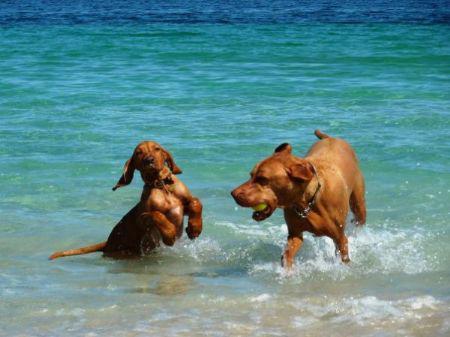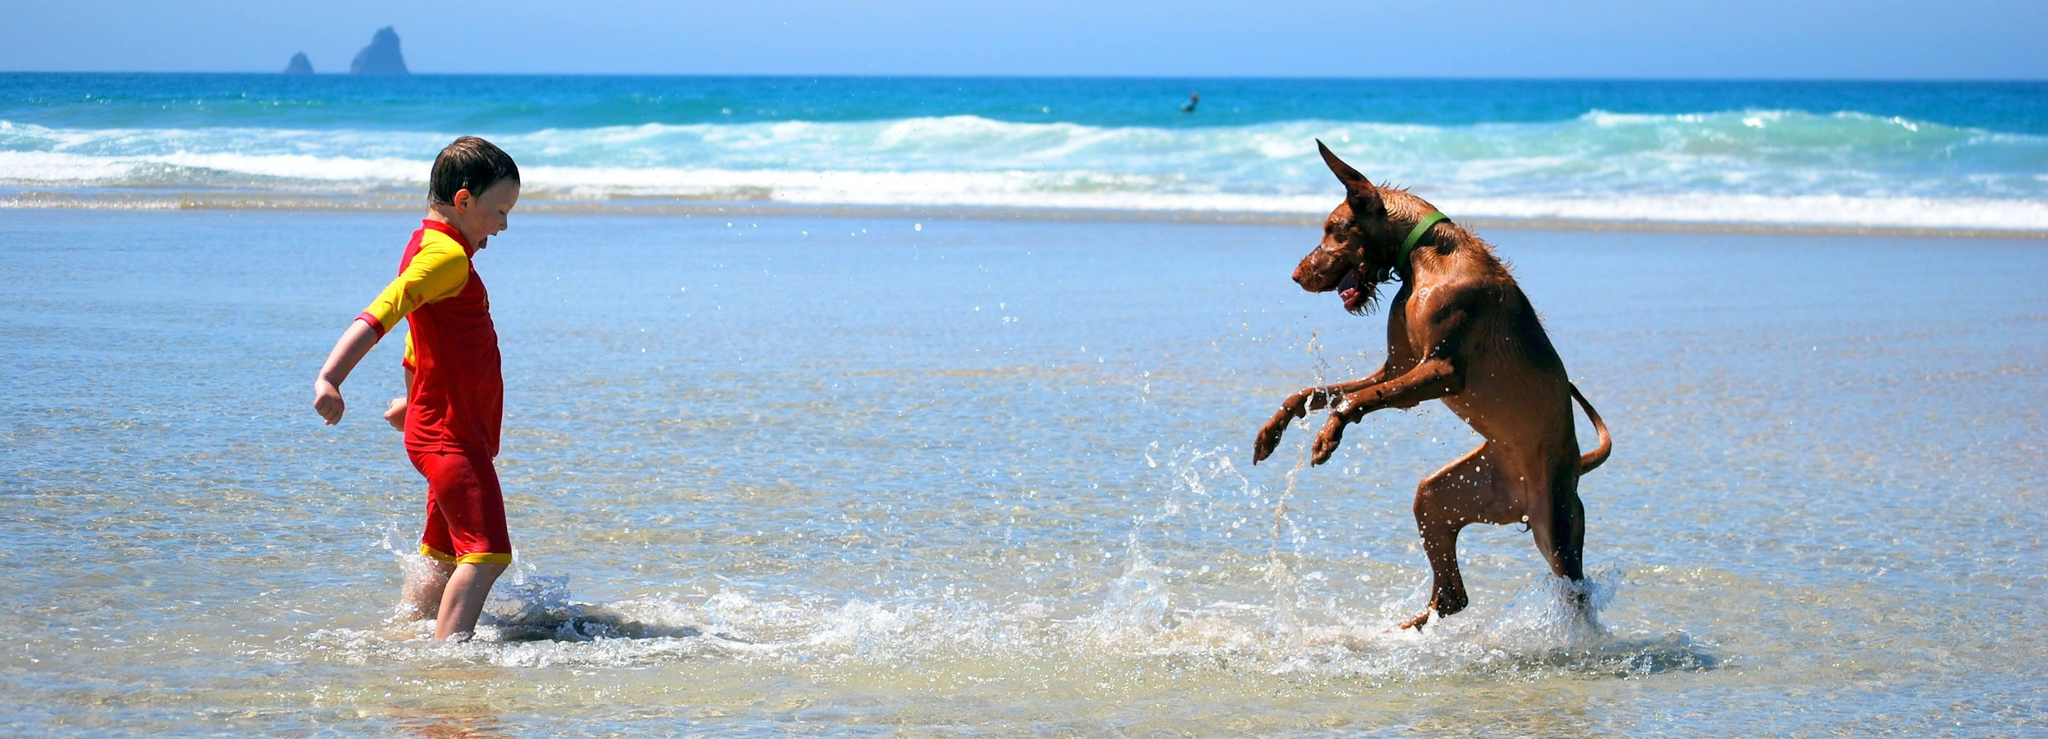The first image is the image on the left, the second image is the image on the right. For the images shown, is this caption "A boy and a dog face toward each other in one image, and two dogs are in a natural body of water in the other image." true? Answer yes or no. Yes. The first image is the image on the left, the second image is the image on the right. Given the left and right images, does the statement "The left image contains exactly two dogs." hold true? Answer yes or no. Yes. 